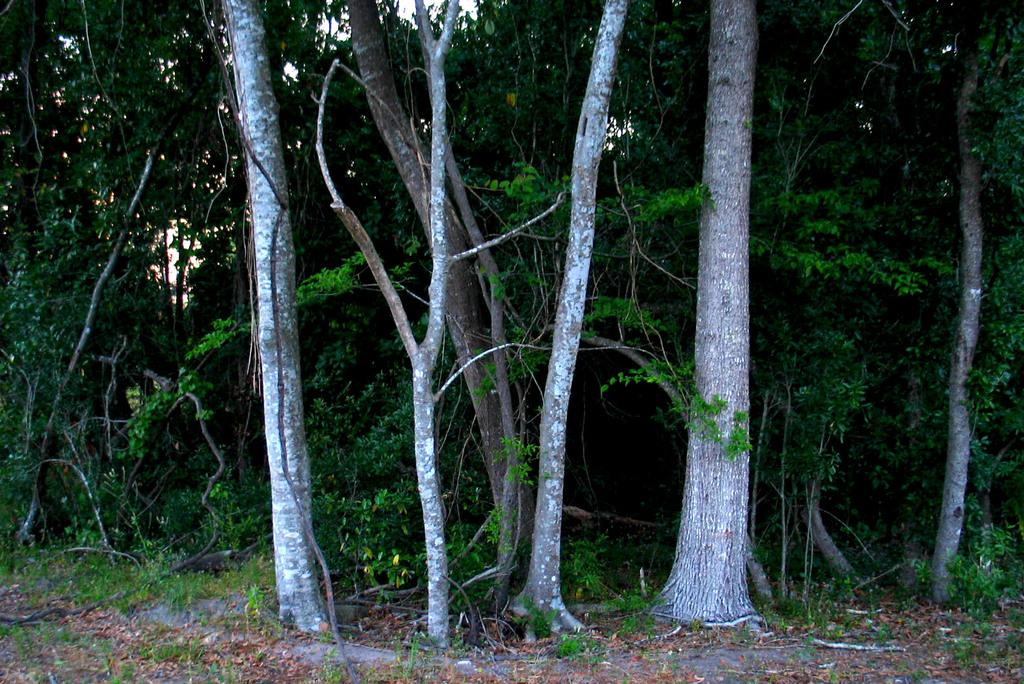What type of vegetation is present in the image? There are trees in the image. What is the color of the trees? The trees are in green color. What else is visible in the image besides the trees? The sky is visible in the image. What might be the actual color of the sky in the image? The actual color of the sky might be blue, but it could have been incorrectly transcribed as white. Can you see any trains passing through the trees in the image? There are no trains present in the image. Is there a cracker flying around with a wing in the image? There is no cracker or wing present in the image. 